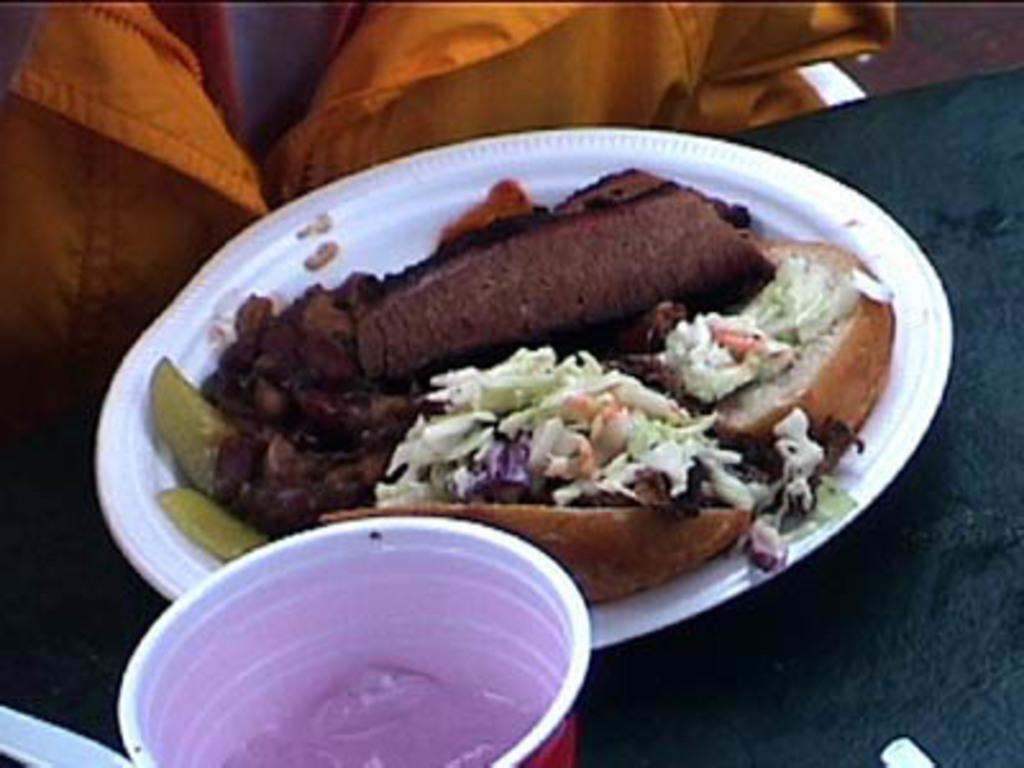What is on the plate in the image? There is food on the plate in the image. Can you describe the appearance of the food on the plate? The food is brown and white in color. What else can be seen in the image besides the plate and food? There is a cup in the image. What type of poison is visible on the plate in the image? There is no poison present in the image; it features a white plate with food on it. What way is the food arranged on the plate in the image? The provided facts do not give information about the arrangement of the food on the plate, so we cannot answer this question. 